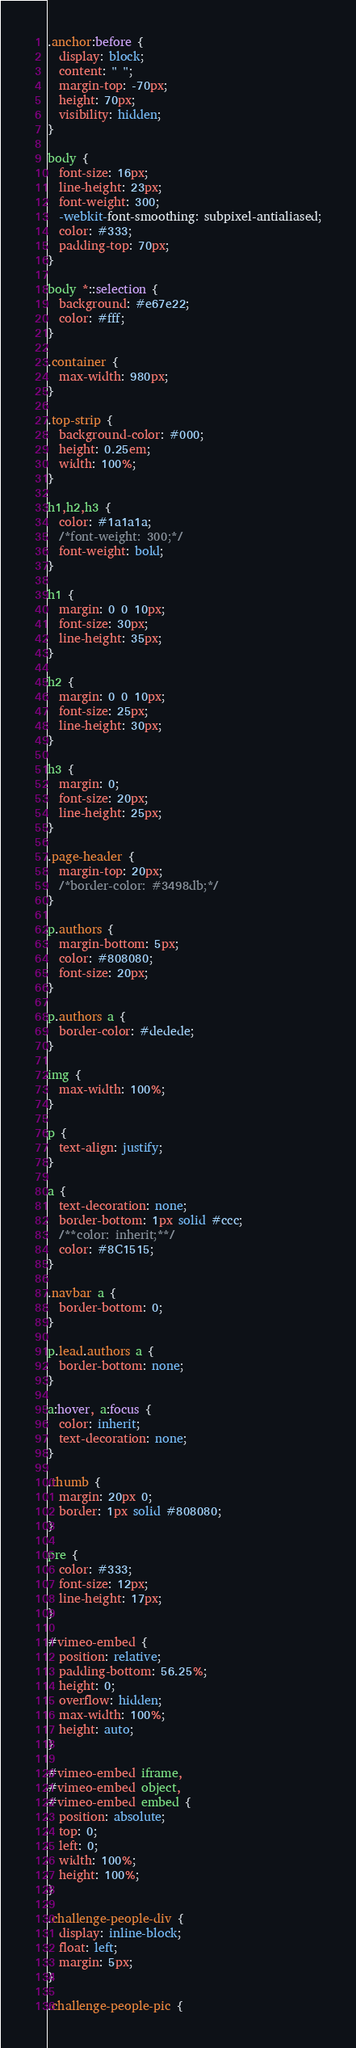<code> <loc_0><loc_0><loc_500><loc_500><_CSS_>.anchor:before {
  display: block;
  content: " ";
  margin-top: -70px;
  height: 70px;
  visibility: hidden;
}

body {
  font-size: 16px;
  line-height: 23px;
  font-weight: 300;
  -webkit-font-smoothing: subpixel-antialiased;
  color: #333;
  padding-top: 70px;
}

body *::selection {
  background: #e67e22;
  color: #fff;
}

.container {
  max-width: 980px;
}

.top-strip {
  background-color: #000;
  height: 0.25em;
  width: 100%;
}

h1,h2,h3 {
  color: #1a1a1a;
  /*font-weight: 300;*/
  font-weight: bold;
}

h1 {
  margin: 0 0 10px;
  font-size: 30px;
  line-height: 35px;
}

h2 {
  margin: 0 0 10px;
  font-size: 25px;
  line-height: 30px;
}

h3 {
  margin: 0;
  font-size: 20px;
  line-height: 25px;
}

.page-header {
  margin-top: 20px;
  /*border-color: #3498db;*/
}

p.authors {
  margin-bottom: 5px;
  color: #808080;
  font-size: 20px;
}

p.authors a {
  border-color: #dedede;
}

img {
  max-width: 100%;
}

p {
  text-align: justify;
}

a {
  text-decoration: none;
  border-bottom: 1px solid #ccc;
  /**color: inherit;**/
  color: #8C1515;
}

.navbar a {
  border-bottom: 0;
}

p.lead.authors a {
  border-bottom: none;
}

a:hover, a:focus {
  color: inherit;
  text-decoration: none;
}

.thumb {
  margin: 20px 0;
  border: 1px solid #808080;
}

pre {
  color: #333;
  font-size: 12px;
  line-height: 17px;
}

#vimeo-embed {
  position: relative;
  padding-bottom: 56.25%;
  height: 0;
  overflow: hidden;
  max-width: 100%;
  height: auto;
}

#vimeo-embed iframe,
#vimeo-embed object,
#vimeo-embed embed {
  position: absolute;
  top: 0;
  left: 0;
  width: 100%;
  height: 100%;
}

.challenge-people-div {
  display: inline-block;
  float: left;
  margin: 5px;
}

.challenge-people-pic {</code> 